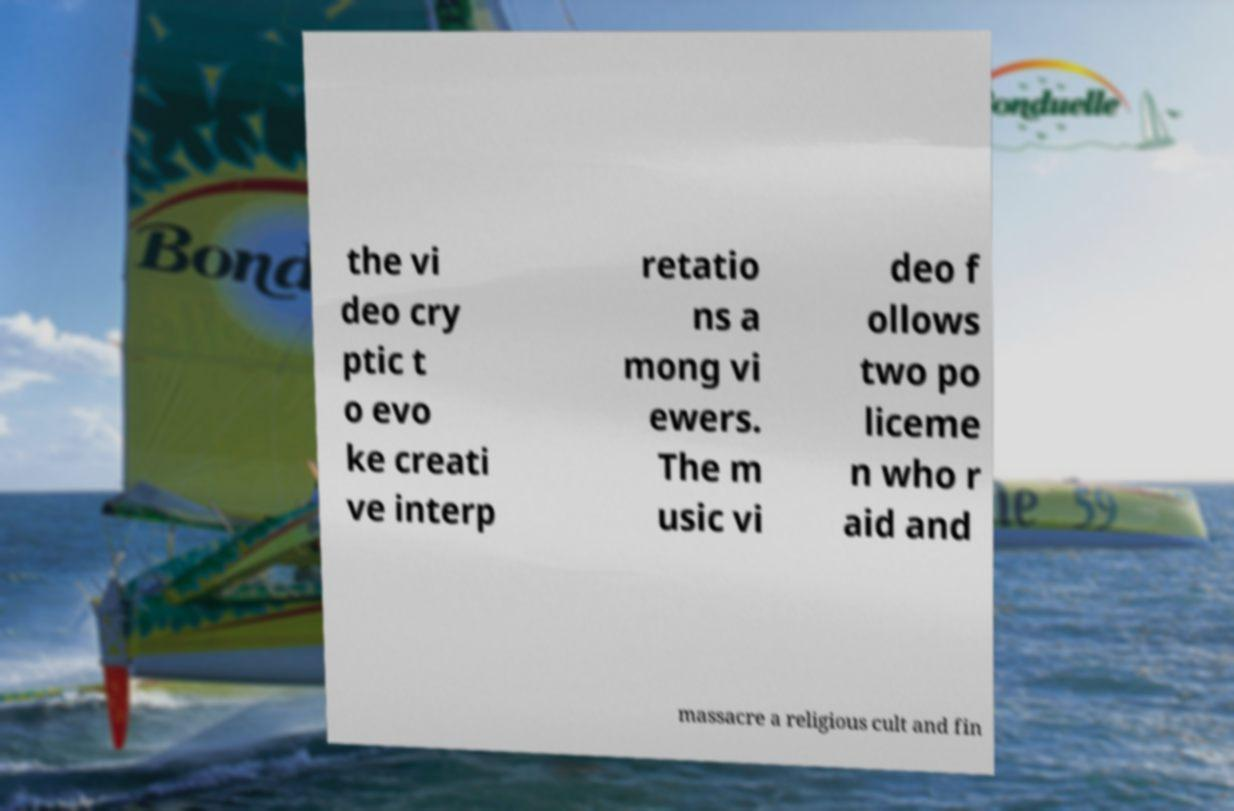For documentation purposes, I need the text within this image transcribed. Could you provide that? the vi deo cry ptic t o evo ke creati ve interp retatio ns a mong vi ewers. The m usic vi deo f ollows two po liceme n who r aid and massacre a religious cult and fin 